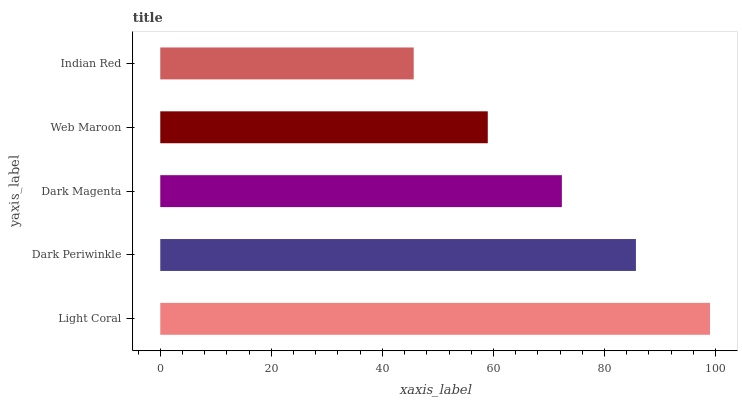Is Indian Red the minimum?
Answer yes or no. Yes. Is Light Coral the maximum?
Answer yes or no. Yes. Is Dark Periwinkle the minimum?
Answer yes or no. No. Is Dark Periwinkle the maximum?
Answer yes or no. No. Is Light Coral greater than Dark Periwinkle?
Answer yes or no. Yes. Is Dark Periwinkle less than Light Coral?
Answer yes or no. Yes. Is Dark Periwinkle greater than Light Coral?
Answer yes or no. No. Is Light Coral less than Dark Periwinkle?
Answer yes or no. No. Is Dark Magenta the high median?
Answer yes or no. Yes. Is Dark Magenta the low median?
Answer yes or no. Yes. Is Dark Periwinkle the high median?
Answer yes or no. No. Is Dark Periwinkle the low median?
Answer yes or no. No. 